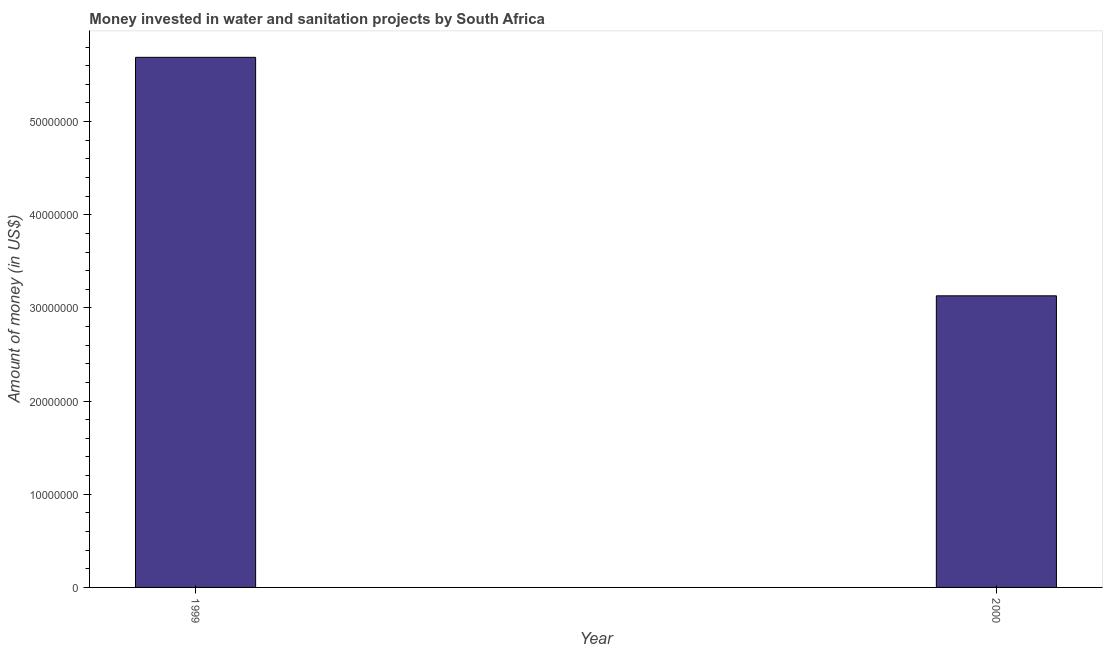Does the graph contain any zero values?
Offer a very short reply. No. Does the graph contain grids?
Make the answer very short. No. What is the title of the graph?
Keep it short and to the point. Money invested in water and sanitation projects by South Africa. What is the label or title of the X-axis?
Your answer should be compact. Year. What is the label or title of the Y-axis?
Offer a very short reply. Amount of money (in US$). What is the investment in 2000?
Your response must be concise. 3.13e+07. Across all years, what is the maximum investment?
Offer a terse response. 5.69e+07. Across all years, what is the minimum investment?
Your answer should be very brief. 3.13e+07. In which year was the investment maximum?
Ensure brevity in your answer.  1999. What is the sum of the investment?
Your answer should be very brief. 8.82e+07. What is the difference between the investment in 1999 and 2000?
Offer a terse response. 2.56e+07. What is the average investment per year?
Your response must be concise. 4.41e+07. What is the median investment?
Provide a succinct answer. 4.41e+07. What is the ratio of the investment in 1999 to that in 2000?
Your answer should be compact. 1.82. In how many years, is the investment greater than the average investment taken over all years?
Your response must be concise. 1. How many years are there in the graph?
Your answer should be very brief. 2. What is the difference between two consecutive major ticks on the Y-axis?
Ensure brevity in your answer.  1.00e+07. What is the Amount of money (in US$) in 1999?
Offer a very short reply. 5.69e+07. What is the Amount of money (in US$) of 2000?
Offer a very short reply. 3.13e+07. What is the difference between the Amount of money (in US$) in 1999 and 2000?
Ensure brevity in your answer.  2.56e+07. What is the ratio of the Amount of money (in US$) in 1999 to that in 2000?
Offer a terse response. 1.82. 